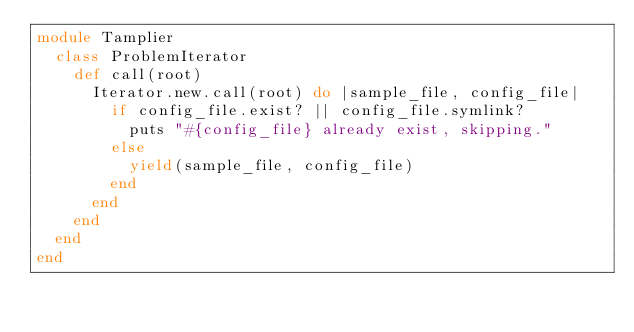Convert code to text. <code><loc_0><loc_0><loc_500><loc_500><_Ruby_>module Tamplier
  class ProblemIterator
    def call(root)
      Iterator.new.call(root) do |sample_file, config_file|
        if config_file.exist? || config_file.symlink?
          puts "#{config_file} already exist, skipping."
        else
          yield(sample_file, config_file)
        end
      end
    end
  end
end</code> 